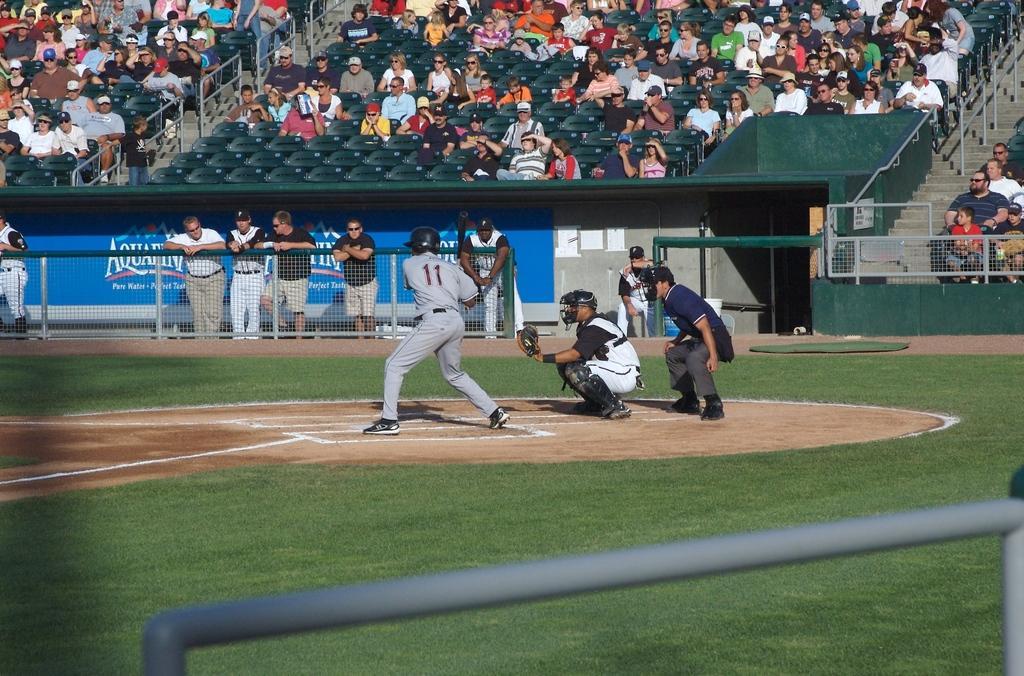Could you give a brief overview of what you see in this image? In the center of the image we can see a group of people standing on the ground, some persons are wearing helmets. In the background, we can see the fence, banner with some text, group of audience sitting on chairs, barricades, some poles and the grass. 